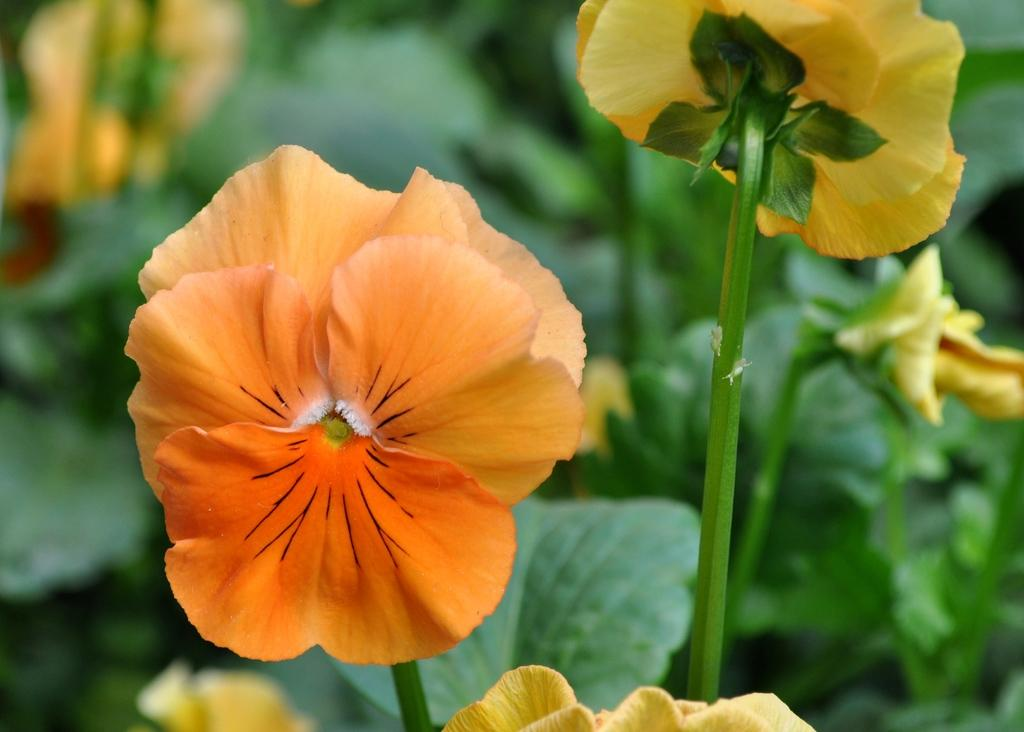What type of living organisms can be seen in the image? Flowers are visible in the image. How many apples are hanging from the beam in the image? There are no apples or beams present in the image; it features flowers. 